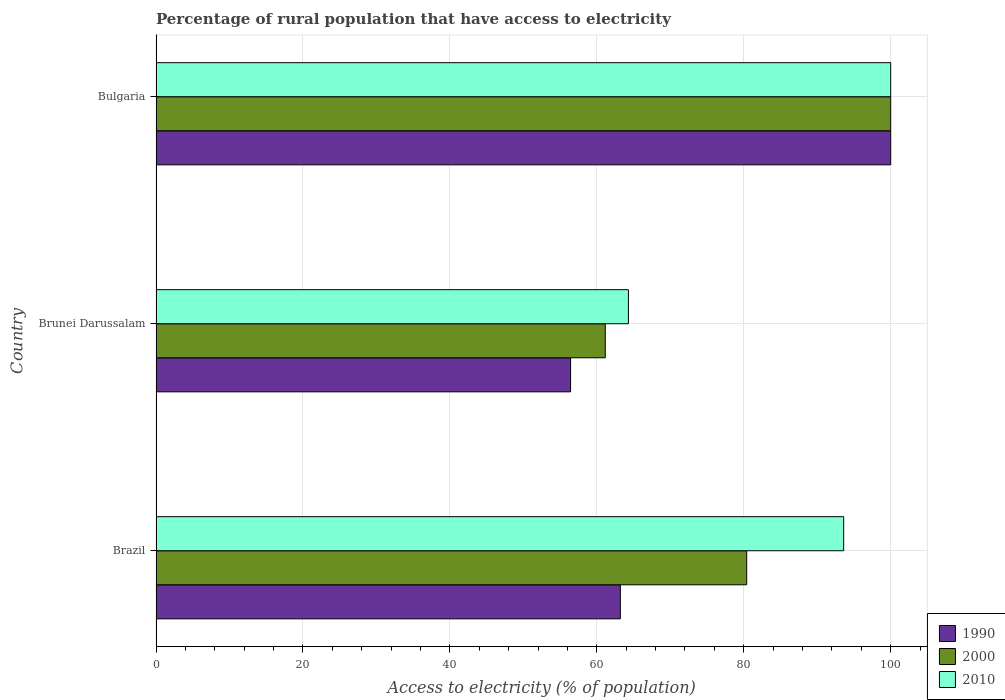How many different coloured bars are there?
Your answer should be very brief. 3. Are the number of bars on each tick of the Y-axis equal?
Offer a terse response. Yes. How many bars are there on the 1st tick from the bottom?
Provide a short and direct response. 3. What is the label of the 1st group of bars from the top?
Keep it short and to the point. Bulgaria. What is the percentage of rural population that have access to electricity in 1990 in Brazil?
Keep it short and to the point. 63.2. Across all countries, what is the maximum percentage of rural population that have access to electricity in 2000?
Offer a terse response. 100. Across all countries, what is the minimum percentage of rural population that have access to electricity in 2010?
Offer a terse response. 64.3. In which country was the percentage of rural population that have access to electricity in 2010 minimum?
Your answer should be compact. Brunei Darussalam. What is the total percentage of rural population that have access to electricity in 1990 in the graph?
Your response must be concise. 219.63. What is the difference between the percentage of rural population that have access to electricity in 2000 in Brunei Darussalam and that in Bulgaria?
Offer a terse response. -38.85. What is the difference between the percentage of rural population that have access to electricity in 1990 in Brunei Darussalam and the percentage of rural population that have access to electricity in 2010 in Brazil?
Provide a short and direct response. -37.17. What is the average percentage of rural population that have access to electricity in 2010 per country?
Offer a terse response. 85.97. What is the difference between the percentage of rural population that have access to electricity in 1990 and percentage of rural population that have access to electricity in 2000 in Brunei Darussalam?
Provide a short and direct response. -4.72. What is the ratio of the percentage of rural population that have access to electricity in 2010 in Brunei Darussalam to that in Bulgaria?
Give a very brief answer. 0.64. Is the percentage of rural population that have access to electricity in 1990 in Brazil less than that in Bulgaria?
Ensure brevity in your answer.  Yes. What is the difference between the highest and the second highest percentage of rural population that have access to electricity in 2000?
Ensure brevity in your answer.  19.6. What is the difference between the highest and the lowest percentage of rural population that have access to electricity in 2010?
Provide a succinct answer. 35.7. In how many countries, is the percentage of rural population that have access to electricity in 2010 greater than the average percentage of rural population that have access to electricity in 2010 taken over all countries?
Your answer should be very brief. 2. Is the sum of the percentage of rural population that have access to electricity in 1990 in Brazil and Bulgaria greater than the maximum percentage of rural population that have access to electricity in 2010 across all countries?
Offer a very short reply. Yes. What does the 2nd bar from the top in Brazil represents?
Give a very brief answer. 2000. Is it the case that in every country, the sum of the percentage of rural population that have access to electricity in 1990 and percentage of rural population that have access to electricity in 2010 is greater than the percentage of rural population that have access to electricity in 2000?
Provide a succinct answer. Yes. How many countries are there in the graph?
Provide a short and direct response. 3. What is the difference between two consecutive major ticks on the X-axis?
Your response must be concise. 20. Are the values on the major ticks of X-axis written in scientific E-notation?
Your answer should be compact. No. Does the graph contain any zero values?
Your answer should be very brief. No. Does the graph contain grids?
Your answer should be compact. Yes. How are the legend labels stacked?
Provide a short and direct response. Vertical. What is the title of the graph?
Offer a terse response. Percentage of rural population that have access to electricity. Does "2004" appear as one of the legend labels in the graph?
Give a very brief answer. No. What is the label or title of the X-axis?
Your answer should be very brief. Access to electricity (% of population). What is the label or title of the Y-axis?
Offer a terse response. Country. What is the Access to electricity (% of population) in 1990 in Brazil?
Provide a short and direct response. 63.2. What is the Access to electricity (% of population) of 2000 in Brazil?
Your response must be concise. 80.4. What is the Access to electricity (% of population) in 2010 in Brazil?
Your answer should be very brief. 93.6. What is the Access to electricity (% of population) in 1990 in Brunei Darussalam?
Keep it short and to the point. 56.43. What is the Access to electricity (% of population) in 2000 in Brunei Darussalam?
Your answer should be very brief. 61.15. What is the Access to electricity (% of population) in 2010 in Brunei Darussalam?
Your answer should be compact. 64.3. What is the Access to electricity (% of population) in 1990 in Bulgaria?
Offer a terse response. 100. What is the Access to electricity (% of population) of 2000 in Bulgaria?
Ensure brevity in your answer.  100. Across all countries, what is the maximum Access to electricity (% of population) of 1990?
Offer a terse response. 100. Across all countries, what is the maximum Access to electricity (% of population) of 2010?
Provide a succinct answer. 100. Across all countries, what is the minimum Access to electricity (% of population) in 1990?
Provide a short and direct response. 56.43. Across all countries, what is the minimum Access to electricity (% of population) in 2000?
Keep it short and to the point. 61.15. Across all countries, what is the minimum Access to electricity (% of population) in 2010?
Keep it short and to the point. 64.3. What is the total Access to electricity (% of population) in 1990 in the graph?
Your response must be concise. 219.63. What is the total Access to electricity (% of population) in 2000 in the graph?
Offer a very short reply. 241.55. What is the total Access to electricity (% of population) in 2010 in the graph?
Provide a short and direct response. 257.9. What is the difference between the Access to electricity (% of population) of 1990 in Brazil and that in Brunei Darussalam?
Your response must be concise. 6.77. What is the difference between the Access to electricity (% of population) in 2000 in Brazil and that in Brunei Darussalam?
Provide a succinct answer. 19.25. What is the difference between the Access to electricity (% of population) in 2010 in Brazil and that in Brunei Darussalam?
Your response must be concise. 29.3. What is the difference between the Access to electricity (% of population) of 1990 in Brazil and that in Bulgaria?
Your response must be concise. -36.8. What is the difference between the Access to electricity (% of population) of 2000 in Brazil and that in Bulgaria?
Offer a very short reply. -19.6. What is the difference between the Access to electricity (% of population) in 1990 in Brunei Darussalam and that in Bulgaria?
Your answer should be compact. -43.57. What is the difference between the Access to electricity (% of population) of 2000 in Brunei Darussalam and that in Bulgaria?
Provide a succinct answer. -38.85. What is the difference between the Access to electricity (% of population) of 2010 in Brunei Darussalam and that in Bulgaria?
Your answer should be very brief. -35.7. What is the difference between the Access to electricity (% of population) in 1990 in Brazil and the Access to electricity (% of population) in 2000 in Brunei Darussalam?
Offer a very short reply. 2.05. What is the difference between the Access to electricity (% of population) of 2000 in Brazil and the Access to electricity (% of population) of 2010 in Brunei Darussalam?
Keep it short and to the point. 16.1. What is the difference between the Access to electricity (% of population) of 1990 in Brazil and the Access to electricity (% of population) of 2000 in Bulgaria?
Ensure brevity in your answer.  -36.8. What is the difference between the Access to electricity (% of population) in 1990 in Brazil and the Access to electricity (% of population) in 2010 in Bulgaria?
Keep it short and to the point. -36.8. What is the difference between the Access to electricity (% of population) of 2000 in Brazil and the Access to electricity (% of population) of 2010 in Bulgaria?
Your answer should be compact. -19.6. What is the difference between the Access to electricity (% of population) in 1990 in Brunei Darussalam and the Access to electricity (% of population) in 2000 in Bulgaria?
Your answer should be compact. -43.57. What is the difference between the Access to electricity (% of population) of 1990 in Brunei Darussalam and the Access to electricity (% of population) of 2010 in Bulgaria?
Keep it short and to the point. -43.57. What is the difference between the Access to electricity (% of population) of 2000 in Brunei Darussalam and the Access to electricity (% of population) of 2010 in Bulgaria?
Provide a succinct answer. -38.85. What is the average Access to electricity (% of population) of 1990 per country?
Your answer should be very brief. 73.21. What is the average Access to electricity (% of population) in 2000 per country?
Offer a very short reply. 80.52. What is the average Access to electricity (% of population) of 2010 per country?
Your answer should be very brief. 85.97. What is the difference between the Access to electricity (% of population) in 1990 and Access to electricity (% of population) in 2000 in Brazil?
Ensure brevity in your answer.  -17.2. What is the difference between the Access to electricity (% of population) in 1990 and Access to electricity (% of population) in 2010 in Brazil?
Provide a short and direct response. -30.4. What is the difference between the Access to electricity (% of population) of 1990 and Access to electricity (% of population) of 2000 in Brunei Darussalam?
Your response must be concise. -4.72. What is the difference between the Access to electricity (% of population) of 1990 and Access to electricity (% of population) of 2010 in Brunei Darussalam?
Provide a succinct answer. -7.87. What is the difference between the Access to electricity (% of population) of 2000 and Access to electricity (% of population) of 2010 in Brunei Darussalam?
Your answer should be compact. -3.15. What is the difference between the Access to electricity (% of population) in 1990 and Access to electricity (% of population) in 2010 in Bulgaria?
Your response must be concise. 0. What is the ratio of the Access to electricity (% of population) in 1990 in Brazil to that in Brunei Darussalam?
Your answer should be very brief. 1.12. What is the ratio of the Access to electricity (% of population) of 2000 in Brazil to that in Brunei Darussalam?
Offer a terse response. 1.31. What is the ratio of the Access to electricity (% of population) in 2010 in Brazil to that in Brunei Darussalam?
Your response must be concise. 1.46. What is the ratio of the Access to electricity (% of population) of 1990 in Brazil to that in Bulgaria?
Your answer should be very brief. 0.63. What is the ratio of the Access to electricity (% of population) of 2000 in Brazil to that in Bulgaria?
Your answer should be compact. 0.8. What is the ratio of the Access to electricity (% of population) of 2010 in Brazil to that in Bulgaria?
Keep it short and to the point. 0.94. What is the ratio of the Access to electricity (% of population) in 1990 in Brunei Darussalam to that in Bulgaria?
Offer a very short reply. 0.56. What is the ratio of the Access to electricity (% of population) of 2000 in Brunei Darussalam to that in Bulgaria?
Keep it short and to the point. 0.61. What is the ratio of the Access to electricity (% of population) of 2010 in Brunei Darussalam to that in Bulgaria?
Make the answer very short. 0.64. What is the difference between the highest and the second highest Access to electricity (% of population) of 1990?
Offer a terse response. 36.8. What is the difference between the highest and the second highest Access to electricity (% of population) of 2000?
Offer a terse response. 19.6. What is the difference between the highest and the second highest Access to electricity (% of population) in 2010?
Your response must be concise. 6.4. What is the difference between the highest and the lowest Access to electricity (% of population) of 1990?
Your response must be concise. 43.57. What is the difference between the highest and the lowest Access to electricity (% of population) of 2000?
Offer a very short reply. 38.85. What is the difference between the highest and the lowest Access to electricity (% of population) in 2010?
Your response must be concise. 35.7. 